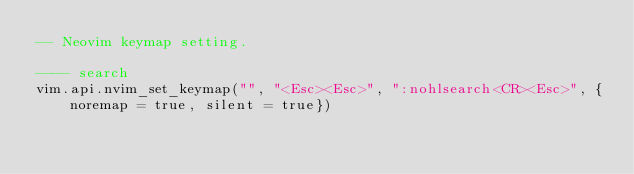Convert code to text. <code><loc_0><loc_0><loc_500><loc_500><_Lua_>-- Neovim keymap setting.

---- search
vim.api.nvim_set_keymap("", "<Esc><Esc>", ":nohlsearch<CR><Esc>", {noremap = true, silent = true})
</code> 